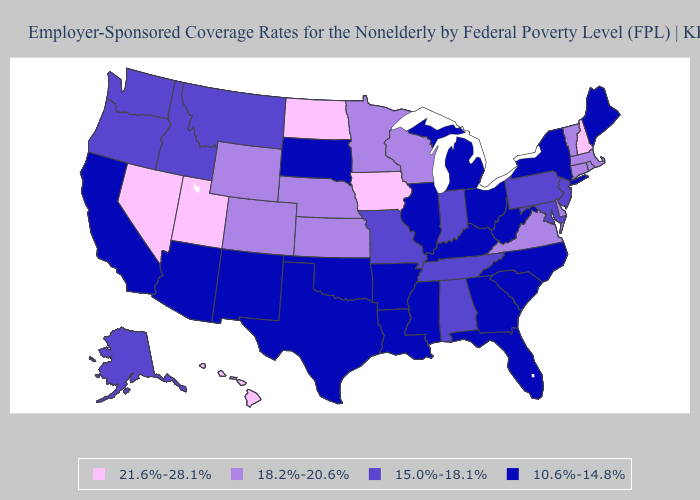Name the states that have a value in the range 18.2%-20.6%?
Keep it brief. Colorado, Connecticut, Delaware, Kansas, Massachusetts, Minnesota, Nebraska, Rhode Island, Vermont, Virginia, Wisconsin, Wyoming. Which states have the lowest value in the West?
Short answer required. Arizona, California, New Mexico. Name the states that have a value in the range 15.0%-18.1%?
Write a very short answer. Alabama, Alaska, Idaho, Indiana, Maryland, Missouri, Montana, New Jersey, Oregon, Pennsylvania, Tennessee, Washington. What is the value of Minnesota?
Write a very short answer. 18.2%-20.6%. What is the highest value in the South ?
Concise answer only. 18.2%-20.6%. What is the lowest value in states that border Massachusetts?
Keep it brief. 10.6%-14.8%. Does Michigan have the highest value in the MidWest?
Be succinct. No. What is the lowest value in states that border Illinois?
Give a very brief answer. 10.6%-14.8%. What is the lowest value in the Northeast?
Answer briefly. 10.6%-14.8%. Which states have the highest value in the USA?
Concise answer only. Hawaii, Iowa, Nevada, New Hampshire, North Dakota, Utah. Name the states that have a value in the range 10.6%-14.8%?
Answer briefly. Arizona, Arkansas, California, Florida, Georgia, Illinois, Kentucky, Louisiana, Maine, Michigan, Mississippi, New Mexico, New York, North Carolina, Ohio, Oklahoma, South Carolina, South Dakota, Texas, West Virginia. Does the map have missing data?
Concise answer only. No. What is the highest value in the USA?
Quick response, please. 21.6%-28.1%. Among the states that border North Dakota , does South Dakota have the lowest value?
Keep it brief. Yes. Name the states that have a value in the range 10.6%-14.8%?
Short answer required. Arizona, Arkansas, California, Florida, Georgia, Illinois, Kentucky, Louisiana, Maine, Michigan, Mississippi, New Mexico, New York, North Carolina, Ohio, Oklahoma, South Carolina, South Dakota, Texas, West Virginia. 